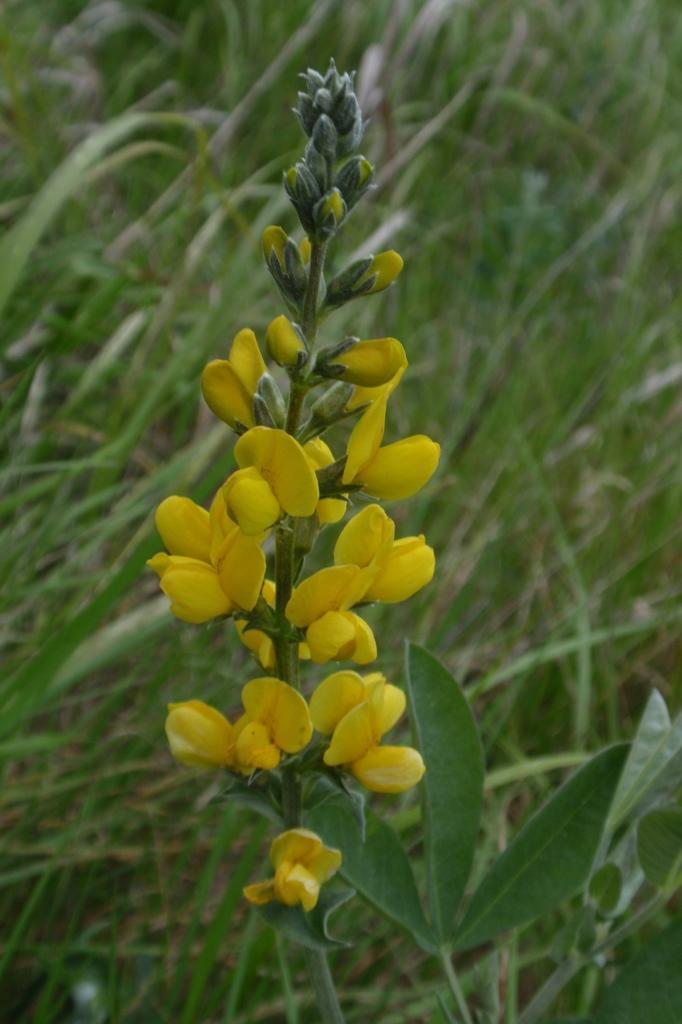Describe this image in one or two sentences. In the image there are yellow flowers to a plant and the background of the plant is blur. 